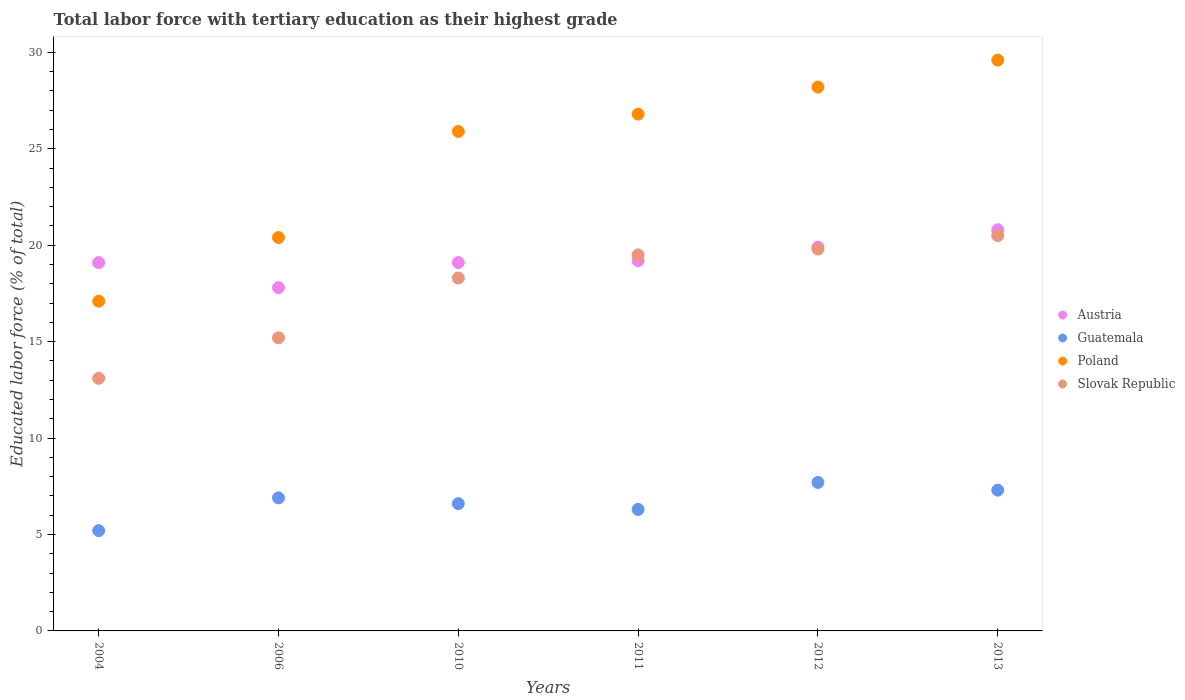What is the percentage of male labor force with tertiary education in Poland in 2010?
Ensure brevity in your answer.  25.9. Across all years, what is the maximum percentage of male labor force with tertiary education in Austria?
Make the answer very short. 20.8. Across all years, what is the minimum percentage of male labor force with tertiary education in Poland?
Your response must be concise. 17.1. What is the total percentage of male labor force with tertiary education in Slovak Republic in the graph?
Your answer should be compact. 106.4. What is the difference between the percentage of male labor force with tertiary education in Slovak Republic in 2010 and that in 2011?
Make the answer very short. -1.2. What is the difference between the percentage of male labor force with tertiary education in Poland in 2011 and the percentage of male labor force with tertiary education in Guatemala in 2012?
Provide a short and direct response. 19.1. What is the average percentage of male labor force with tertiary education in Austria per year?
Provide a short and direct response. 19.32. In the year 2006, what is the difference between the percentage of male labor force with tertiary education in Guatemala and percentage of male labor force with tertiary education in Slovak Republic?
Your response must be concise. -8.3. What is the ratio of the percentage of male labor force with tertiary education in Guatemala in 2004 to that in 2010?
Your answer should be compact. 0.79. What is the difference between the highest and the second highest percentage of male labor force with tertiary education in Guatemala?
Make the answer very short. 0.4. What is the difference between the highest and the lowest percentage of male labor force with tertiary education in Guatemala?
Provide a succinct answer. 2.5. In how many years, is the percentage of male labor force with tertiary education in Guatemala greater than the average percentage of male labor force with tertiary education in Guatemala taken over all years?
Ensure brevity in your answer.  3. Is the sum of the percentage of male labor force with tertiary education in Poland in 2004 and 2013 greater than the maximum percentage of male labor force with tertiary education in Guatemala across all years?
Your response must be concise. Yes. Is it the case that in every year, the sum of the percentage of male labor force with tertiary education in Poland and percentage of male labor force with tertiary education in Slovak Republic  is greater than the sum of percentage of male labor force with tertiary education in Austria and percentage of male labor force with tertiary education in Guatemala?
Your answer should be very brief. No. Is the percentage of male labor force with tertiary education in Guatemala strictly greater than the percentage of male labor force with tertiary education in Austria over the years?
Provide a succinct answer. No. How many dotlines are there?
Your response must be concise. 4. What is the difference between two consecutive major ticks on the Y-axis?
Ensure brevity in your answer.  5. Are the values on the major ticks of Y-axis written in scientific E-notation?
Offer a very short reply. No. Where does the legend appear in the graph?
Provide a succinct answer. Center right. What is the title of the graph?
Provide a short and direct response. Total labor force with tertiary education as their highest grade. Does "Europe(developing only)" appear as one of the legend labels in the graph?
Make the answer very short. No. What is the label or title of the X-axis?
Offer a terse response. Years. What is the label or title of the Y-axis?
Offer a terse response. Educated labor force (% of total). What is the Educated labor force (% of total) in Austria in 2004?
Offer a very short reply. 19.1. What is the Educated labor force (% of total) of Guatemala in 2004?
Offer a terse response. 5.2. What is the Educated labor force (% of total) in Poland in 2004?
Your response must be concise. 17.1. What is the Educated labor force (% of total) of Slovak Republic in 2004?
Offer a terse response. 13.1. What is the Educated labor force (% of total) in Austria in 2006?
Your answer should be compact. 17.8. What is the Educated labor force (% of total) of Guatemala in 2006?
Provide a succinct answer. 6.9. What is the Educated labor force (% of total) in Poland in 2006?
Offer a very short reply. 20.4. What is the Educated labor force (% of total) in Slovak Republic in 2006?
Offer a very short reply. 15.2. What is the Educated labor force (% of total) in Austria in 2010?
Your answer should be very brief. 19.1. What is the Educated labor force (% of total) in Guatemala in 2010?
Keep it short and to the point. 6.6. What is the Educated labor force (% of total) in Poland in 2010?
Give a very brief answer. 25.9. What is the Educated labor force (% of total) of Slovak Republic in 2010?
Give a very brief answer. 18.3. What is the Educated labor force (% of total) in Austria in 2011?
Make the answer very short. 19.2. What is the Educated labor force (% of total) of Guatemala in 2011?
Offer a very short reply. 6.3. What is the Educated labor force (% of total) of Poland in 2011?
Ensure brevity in your answer.  26.8. What is the Educated labor force (% of total) in Slovak Republic in 2011?
Your response must be concise. 19.5. What is the Educated labor force (% of total) of Austria in 2012?
Provide a succinct answer. 19.9. What is the Educated labor force (% of total) in Guatemala in 2012?
Give a very brief answer. 7.7. What is the Educated labor force (% of total) of Poland in 2012?
Your answer should be very brief. 28.2. What is the Educated labor force (% of total) in Slovak Republic in 2012?
Your response must be concise. 19.8. What is the Educated labor force (% of total) in Austria in 2013?
Give a very brief answer. 20.8. What is the Educated labor force (% of total) of Guatemala in 2013?
Give a very brief answer. 7.3. What is the Educated labor force (% of total) in Poland in 2013?
Your response must be concise. 29.6. Across all years, what is the maximum Educated labor force (% of total) of Austria?
Provide a succinct answer. 20.8. Across all years, what is the maximum Educated labor force (% of total) in Guatemala?
Your answer should be compact. 7.7. Across all years, what is the maximum Educated labor force (% of total) in Poland?
Provide a succinct answer. 29.6. Across all years, what is the minimum Educated labor force (% of total) of Austria?
Offer a terse response. 17.8. Across all years, what is the minimum Educated labor force (% of total) in Guatemala?
Offer a terse response. 5.2. Across all years, what is the minimum Educated labor force (% of total) of Poland?
Your response must be concise. 17.1. Across all years, what is the minimum Educated labor force (% of total) in Slovak Republic?
Offer a terse response. 13.1. What is the total Educated labor force (% of total) in Austria in the graph?
Make the answer very short. 115.9. What is the total Educated labor force (% of total) of Guatemala in the graph?
Give a very brief answer. 40. What is the total Educated labor force (% of total) in Poland in the graph?
Your response must be concise. 148. What is the total Educated labor force (% of total) of Slovak Republic in the graph?
Provide a short and direct response. 106.4. What is the difference between the Educated labor force (% of total) in Poland in 2004 and that in 2006?
Offer a terse response. -3.3. What is the difference between the Educated labor force (% of total) of Slovak Republic in 2004 and that in 2006?
Your response must be concise. -2.1. What is the difference between the Educated labor force (% of total) in Guatemala in 2004 and that in 2010?
Make the answer very short. -1.4. What is the difference between the Educated labor force (% of total) of Poland in 2004 and that in 2010?
Your answer should be very brief. -8.8. What is the difference between the Educated labor force (% of total) in Poland in 2004 and that in 2011?
Your response must be concise. -9.7. What is the difference between the Educated labor force (% of total) of Slovak Republic in 2004 and that in 2011?
Provide a succinct answer. -6.4. What is the difference between the Educated labor force (% of total) in Austria in 2004 and that in 2012?
Your response must be concise. -0.8. What is the difference between the Educated labor force (% of total) in Austria in 2004 and that in 2013?
Give a very brief answer. -1.7. What is the difference between the Educated labor force (% of total) in Poland in 2004 and that in 2013?
Give a very brief answer. -12.5. What is the difference between the Educated labor force (% of total) of Slovak Republic in 2004 and that in 2013?
Give a very brief answer. -7.4. What is the difference between the Educated labor force (% of total) of Guatemala in 2006 and that in 2010?
Ensure brevity in your answer.  0.3. What is the difference between the Educated labor force (% of total) in Slovak Republic in 2006 and that in 2010?
Your answer should be very brief. -3.1. What is the difference between the Educated labor force (% of total) in Slovak Republic in 2006 and that in 2011?
Give a very brief answer. -4.3. What is the difference between the Educated labor force (% of total) in Austria in 2006 and that in 2012?
Your answer should be compact. -2.1. What is the difference between the Educated labor force (% of total) of Slovak Republic in 2006 and that in 2012?
Offer a very short reply. -4.6. What is the difference between the Educated labor force (% of total) in Slovak Republic in 2006 and that in 2013?
Provide a succinct answer. -5.3. What is the difference between the Educated labor force (% of total) in Poland in 2010 and that in 2012?
Your response must be concise. -2.3. What is the difference between the Educated labor force (% of total) in Slovak Republic in 2010 and that in 2012?
Make the answer very short. -1.5. What is the difference between the Educated labor force (% of total) of Austria in 2010 and that in 2013?
Your response must be concise. -1.7. What is the difference between the Educated labor force (% of total) in Guatemala in 2010 and that in 2013?
Offer a terse response. -0.7. What is the difference between the Educated labor force (% of total) of Slovak Republic in 2010 and that in 2013?
Provide a succinct answer. -2.2. What is the difference between the Educated labor force (% of total) in Poland in 2011 and that in 2012?
Give a very brief answer. -1.4. What is the difference between the Educated labor force (% of total) of Slovak Republic in 2011 and that in 2012?
Your answer should be very brief. -0.3. What is the difference between the Educated labor force (% of total) in Austria in 2011 and that in 2013?
Offer a very short reply. -1.6. What is the difference between the Educated labor force (% of total) in Poland in 2011 and that in 2013?
Provide a short and direct response. -2.8. What is the difference between the Educated labor force (% of total) in Guatemala in 2004 and the Educated labor force (% of total) in Poland in 2006?
Ensure brevity in your answer.  -15.2. What is the difference between the Educated labor force (% of total) of Guatemala in 2004 and the Educated labor force (% of total) of Slovak Republic in 2006?
Offer a terse response. -10. What is the difference between the Educated labor force (% of total) in Poland in 2004 and the Educated labor force (% of total) in Slovak Republic in 2006?
Your answer should be very brief. 1.9. What is the difference between the Educated labor force (% of total) in Guatemala in 2004 and the Educated labor force (% of total) in Poland in 2010?
Make the answer very short. -20.7. What is the difference between the Educated labor force (% of total) of Poland in 2004 and the Educated labor force (% of total) of Slovak Republic in 2010?
Offer a terse response. -1.2. What is the difference between the Educated labor force (% of total) in Austria in 2004 and the Educated labor force (% of total) in Slovak Republic in 2011?
Keep it short and to the point. -0.4. What is the difference between the Educated labor force (% of total) of Guatemala in 2004 and the Educated labor force (% of total) of Poland in 2011?
Provide a succinct answer. -21.6. What is the difference between the Educated labor force (% of total) in Guatemala in 2004 and the Educated labor force (% of total) in Slovak Republic in 2011?
Ensure brevity in your answer.  -14.3. What is the difference between the Educated labor force (% of total) in Poland in 2004 and the Educated labor force (% of total) in Slovak Republic in 2011?
Provide a short and direct response. -2.4. What is the difference between the Educated labor force (% of total) in Austria in 2004 and the Educated labor force (% of total) in Guatemala in 2012?
Your answer should be compact. 11.4. What is the difference between the Educated labor force (% of total) of Austria in 2004 and the Educated labor force (% of total) of Poland in 2012?
Your answer should be very brief. -9.1. What is the difference between the Educated labor force (% of total) of Austria in 2004 and the Educated labor force (% of total) of Slovak Republic in 2012?
Offer a very short reply. -0.7. What is the difference between the Educated labor force (% of total) in Guatemala in 2004 and the Educated labor force (% of total) in Slovak Republic in 2012?
Ensure brevity in your answer.  -14.6. What is the difference between the Educated labor force (% of total) in Poland in 2004 and the Educated labor force (% of total) in Slovak Republic in 2012?
Offer a very short reply. -2.7. What is the difference between the Educated labor force (% of total) of Austria in 2004 and the Educated labor force (% of total) of Slovak Republic in 2013?
Make the answer very short. -1.4. What is the difference between the Educated labor force (% of total) of Guatemala in 2004 and the Educated labor force (% of total) of Poland in 2013?
Give a very brief answer. -24.4. What is the difference between the Educated labor force (% of total) in Guatemala in 2004 and the Educated labor force (% of total) in Slovak Republic in 2013?
Offer a terse response. -15.3. What is the difference between the Educated labor force (% of total) of Poland in 2004 and the Educated labor force (% of total) of Slovak Republic in 2013?
Your response must be concise. -3.4. What is the difference between the Educated labor force (% of total) in Austria in 2006 and the Educated labor force (% of total) in Slovak Republic in 2010?
Make the answer very short. -0.5. What is the difference between the Educated labor force (% of total) in Guatemala in 2006 and the Educated labor force (% of total) in Poland in 2010?
Provide a short and direct response. -19. What is the difference between the Educated labor force (% of total) of Poland in 2006 and the Educated labor force (% of total) of Slovak Republic in 2010?
Your answer should be very brief. 2.1. What is the difference between the Educated labor force (% of total) in Austria in 2006 and the Educated labor force (% of total) in Poland in 2011?
Provide a succinct answer. -9. What is the difference between the Educated labor force (% of total) in Austria in 2006 and the Educated labor force (% of total) in Slovak Republic in 2011?
Offer a terse response. -1.7. What is the difference between the Educated labor force (% of total) of Guatemala in 2006 and the Educated labor force (% of total) of Poland in 2011?
Provide a succinct answer. -19.9. What is the difference between the Educated labor force (% of total) of Guatemala in 2006 and the Educated labor force (% of total) of Slovak Republic in 2011?
Ensure brevity in your answer.  -12.6. What is the difference between the Educated labor force (% of total) of Poland in 2006 and the Educated labor force (% of total) of Slovak Republic in 2011?
Ensure brevity in your answer.  0.9. What is the difference between the Educated labor force (% of total) of Austria in 2006 and the Educated labor force (% of total) of Slovak Republic in 2012?
Your answer should be very brief. -2. What is the difference between the Educated labor force (% of total) of Guatemala in 2006 and the Educated labor force (% of total) of Poland in 2012?
Your answer should be very brief. -21.3. What is the difference between the Educated labor force (% of total) of Guatemala in 2006 and the Educated labor force (% of total) of Slovak Republic in 2012?
Provide a succinct answer. -12.9. What is the difference between the Educated labor force (% of total) in Austria in 2006 and the Educated labor force (% of total) in Slovak Republic in 2013?
Provide a short and direct response. -2.7. What is the difference between the Educated labor force (% of total) in Guatemala in 2006 and the Educated labor force (% of total) in Poland in 2013?
Offer a very short reply. -22.7. What is the difference between the Educated labor force (% of total) of Austria in 2010 and the Educated labor force (% of total) of Guatemala in 2011?
Your response must be concise. 12.8. What is the difference between the Educated labor force (% of total) in Austria in 2010 and the Educated labor force (% of total) in Slovak Republic in 2011?
Give a very brief answer. -0.4. What is the difference between the Educated labor force (% of total) in Guatemala in 2010 and the Educated labor force (% of total) in Poland in 2011?
Offer a very short reply. -20.2. What is the difference between the Educated labor force (% of total) of Guatemala in 2010 and the Educated labor force (% of total) of Slovak Republic in 2011?
Your answer should be very brief. -12.9. What is the difference between the Educated labor force (% of total) in Austria in 2010 and the Educated labor force (% of total) in Poland in 2012?
Provide a succinct answer. -9.1. What is the difference between the Educated labor force (% of total) of Austria in 2010 and the Educated labor force (% of total) of Slovak Republic in 2012?
Provide a succinct answer. -0.7. What is the difference between the Educated labor force (% of total) of Guatemala in 2010 and the Educated labor force (% of total) of Poland in 2012?
Ensure brevity in your answer.  -21.6. What is the difference between the Educated labor force (% of total) in Poland in 2010 and the Educated labor force (% of total) in Slovak Republic in 2012?
Make the answer very short. 6.1. What is the difference between the Educated labor force (% of total) of Austria in 2010 and the Educated labor force (% of total) of Guatemala in 2013?
Give a very brief answer. 11.8. What is the difference between the Educated labor force (% of total) in Austria in 2010 and the Educated labor force (% of total) in Poland in 2013?
Offer a very short reply. -10.5. What is the difference between the Educated labor force (% of total) of Guatemala in 2010 and the Educated labor force (% of total) of Slovak Republic in 2013?
Provide a succinct answer. -13.9. What is the difference between the Educated labor force (% of total) of Poland in 2010 and the Educated labor force (% of total) of Slovak Republic in 2013?
Provide a succinct answer. 5.4. What is the difference between the Educated labor force (% of total) of Austria in 2011 and the Educated labor force (% of total) of Guatemala in 2012?
Your response must be concise. 11.5. What is the difference between the Educated labor force (% of total) in Austria in 2011 and the Educated labor force (% of total) in Slovak Republic in 2012?
Your response must be concise. -0.6. What is the difference between the Educated labor force (% of total) of Guatemala in 2011 and the Educated labor force (% of total) of Poland in 2012?
Your response must be concise. -21.9. What is the difference between the Educated labor force (% of total) in Guatemala in 2011 and the Educated labor force (% of total) in Slovak Republic in 2012?
Provide a short and direct response. -13.5. What is the difference between the Educated labor force (% of total) in Poland in 2011 and the Educated labor force (% of total) in Slovak Republic in 2012?
Provide a succinct answer. 7. What is the difference between the Educated labor force (% of total) of Austria in 2011 and the Educated labor force (% of total) of Guatemala in 2013?
Ensure brevity in your answer.  11.9. What is the difference between the Educated labor force (% of total) in Guatemala in 2011 and the Educated labor force (% of total) in Poland in 2013?
Keep it short and to the point. -23.3. What is the difference between the Educated labor force (% of total) of Poland in 2011 and the Educated labor force (% of total) of Slovak Republic in 2013?
Your answer should be compact. 6.3. What is the difference between the Educated labor force (% of total) in Austria in 2012 and the Educated labor force (% of total) in Guatemala in 2013?
Your response must be concise. 12.6. What is the difference between the Educated labor force (% of total) in Austria in 2012 and the Educated labor force (% of total) in Slovak Republic in 2013?
Provide a succinct answer. -0.6. What is the difference between the Educated labor force (% of total) in Guatemala in 2012 and the Educated labor force (% of total) in Poland in 2013?
Ensure brevity in your answer.  -21.9. What is the difference between the Educated labor force (% of total) in Poland in 2012 and the Educated labor force (% of total) in Slovak Republic in 2013?
Ensure brevity in your answer.  7.7. What is the average Educated labor force (% of total) in Austria per year?
Offer a very short reply. 19.32. What is the average Educated labor force (% of total) of Poland per year?
Your answer should be very brief. 24.67. What is the average Educated labor force (% of total) of Slovak Republic per year?
Provide a short and direct response. 17.73. In the year 2004, what is the difference between the Educated labor force (% of total) of Austria and Educated labor force (% of total) of Guatemala?
Your response must be concise. 13.9. In the year 2004, what is the difference between the Educated labor force (% of total) in Guatemala and Educated labor force (% of total) in Slovak Republic?
Provide a succinct answer. -7.9. In the year 2004, what is the difference between the Educated labor force (% of total) in Poland and Educated labor force (% of total) in Slovak Republic?
Your response must be concise. 4. In the year 2006, what is the difference between the Educated labor force (% of total) of Austria and Educated labor force (% of total) of Guatemala?
Offer a very short reply. 10.9. In the year 2006, what is the difference between the Educated labor force (% of total) of Austria and Educated labor force (% of total) of Poland?
Ensure brevity in your answer.  -2.6. In the year 2006, what is the difference between the Educated labor force (% of total) in Austria and Educated labor force (% of total) in Slovak Republic?
Offer a terse response. 2.6. In the year 2006, what is the difference between the Educated labor force (% of total) in Guatemala and Educated labor force (% of total) in Poland?
Keep it short and to the point. -13.5. In the year 2010, what is the difference between the Educated labor force (% of total) of Austria and Educated labor force (% of total) of Guatemala?
Ensure brevity in your answer.  12.5. In the year 2010, what is the difference between the Educated labor force (% of total) of Austria and Educated labor force (% of total) of Poland?
Offer a very short reply. -6.8. In the year 2010, what is the difference between the Educated labor force (% of total) of Guatemala and Educated labor force (% of total) of Poland?
Give a very brief answer. -19.3. In the year 2010, what is the difference between the Educated labor force (% of total) in Poland and Educated labor force (% of total) in Slovak Republic?
Ensure brevity in your answer.  7.6. In the year 2011, what is the difference between the Educated labor force (% of total) of Austria and Educated labor force (% of total) of Poland?
Your response must be concise. -7.6. In the year 2011, what is the difference between the Educated labor force (% of total) of Austria and Educated labor force (% of total) of Slovak Republic?
Offer a very short reply. -0.3. In the year 2011, what is the difference between the Educated labor force (% of total) of Guatemala and Educated labor force (% of total) of Poland?
Your answer should be very brief. -20.5. In the year 2011, what is the difference between the Educated labor force (% of total) in Guatemala and Educated labor force (% of total) in Slovak Republic?
Provide a short and direct response. -13.2. In the year 2011, what is the difference between the Educated labor force (% of total) of Poland and Educated labor force (% of total) of Slovak Republic?
Offer a terse response. 7.3. In the year 2012, what is the difference between the Educated labor force (% of total) in Austria and Educated labor force (% of total) in Guatemala?
Offer a very short reply. 12.2. In the year 2012, what is the difference between the Educated labor force (% of total) in Guatemala and Educated labor force (% of total) in Poland?
Offer a terse response. -20.5. In the year 2013, what is the difference between the Educated labor force (% of total) in Austria and Educated labor force (% of total) in Guatemala?
Provide a short and direct response. 13.5. In the year 2013, what is the difference between the Educated labor force (% of total) in Austria and Educated labor force (% of total) in Poland?
Offer a terse response. -8.8. In the year 2013, what is the difference between the Educated labor force (% of total) in Austria and Educated labor force (% of total) in Slovak Republic?
Provide a short and direct response. 0.3. In the year 2013, what is the difference between the Educated labor force (% of total) of Guatemala and Educated labor force (% of total) of Poland?
Offer a very short reply. -22.3. In the year 2013, what is the difference between the Educated labor force (% of total) of Guatemala and Educated labor force (% of total) of Slovak Republic?
Ensure brevity in your answer.  -13.2. In the year 2013, what is the difference between the Educated labor force (% of total) in Poland and Educated labor force (% of total) in Slovak Republic?
Your response must be concise. 9.1. What is the ratio of the Educated labor force (% of total) in Austria in 2004 to that in 2006?
Provide a short and direct response. 1.07. What is the ratio of the Educated labor force (% of total) of Guatemala in 2004 to that in 2006?
Your answer should be very brief. 0.75. What is the ratio of the Educated labor force (% of total) of Poland in 2004 to that in 2006?
Your answer should be compact. 0.84. What is the ratio of the Educated labor force (% of total) of Slovak Republic in 2004 to that in 2006?
Provide a succinct answer. 0.86. What is the ratio of the Educated labor force (% of total) in Guatemala in 2004 to that in 2010?
Your answer should be very brief. 0.79. What is the ratio of the Educated labor force (% of total) of Poland in 2004 to that in 2010?
Offer a terse response. 0.66. What is the ratio of the Educated labor force (% of total) of Slovak Republic in 2004 to that in 2010?
Your response must be concise. 0.72. What is the ratio of the Educated labor force (% of total) of Guatemala in 2004 to that in 2011?
Give a very brief answer. 0.83. What is the ratio of the Educated labor force (% of total) in Poland in 2004 to that in 2011?
Your answer should be very brief. 0.64. What is the ratio of the Educated labor force (% of total) of Slovak Republic in 2004 to that in 2011?
Make the answer very short. 0.67. What is the ratio of the Educated labor force (% of total) in Austria in 2004 to that in 2012?
Offer a very short reply. 0.96. What is the ratio of the Educated labor force (% of total) in Guatemala in 2004 to that in 2012?
Offer a very short reply. 0.68. What is the ratio of the Educated labor force (% of total) in Poland in 2004 to that in 2012?
Your answer should be compact. 0.61. What is the ratio of the Educated labor force (% of total) in Slovak Republic in 2004 to that in 2012?
Your answer should be very brief. 0.66. What is the ratio of the Educated labor force (% of total) of Austria in 2004 to that in 2013?
Your answer should be very brief. 0.92. What is the ratio of the Educated labor force (% of total) of Guatemala in 2004 to that in 2013?
Your answer should be very brief. 0.71. What is the ratio of the Educated labor force (% of total) in Poland in 2004 to that in 2013?
Offer a terse response. 0.58. What is the ratio of the Educated labor force (% of total) of Slovak Republic in 2004 to that in 2013?
Your answer should be compact. 0.64. What is the ratio of the Educated labor force (% of total) of Austria in 2006 to that in 2010?
Your answer should be very brief. 0.93. What is the ratio of the Educated labor force (% of total) in Guatemala in 2006 to that in 2010?
Keep it short and to the point. 1.05. What is the ratio of the Educated labor force (% of total) in Poland in 2006 to that in 2010?
Make the answer very short. 0.79. What is the ratio of the Educated labor force (% of total) in Slovak Republic in 2006 to that in 2010?
Your response must be concise. 0.83. What is the ratio of the Educated labor force (% of total) in Austria in 2006 to that in 2011?
Your response must be concise. 0.93. What is the ratio of the Educated labor force (% of total) of Guatemala in 2006 to that in 2011?
Your answer should be very brief. 1.1. What is the ratio of the Educated labor force (% of total) in Poland in 2006 to that in 2011?
Your answer should be compact. 0.76. What is the ratio of the Educated labor force (% of total) in Slovak Republic in 2006 to that in 2011?
Provide a short and direct response. 0.78. What is the ratio of the Educated labor force (% of total) of Austria in 2006 to that in 2012?
Keep it short and to the point. 0.89. What is the ratio of the Educated labor force (% of total) in Guatemala in 2006 to that in 2012?
Offer a very short reply. 0.9. What is the ratio of the Educated labor force (% of total) in Poland in 2006 to that in 2012?
Keep it short and to the point. 0.72. What is the ratio of the Educated labor force (% of total) in Slovak Republic in 2006 to that in 2012?
Ensure brevity in your answer.  0.77. What is the ratio of the Educated labor force (% of total) in Austria in 2006 to that in 2013?
Offer a terse response. 0.86. What is the ratio of the Educated labor force (% of total) in Guatemala in 2006 to that in 2013?
Provide a succinct answer. 0.95. What is the ratio of the Educated labor force (% of total) in Poland in 2006 to that in 2013?
Your response must be concise. 0.69. What is the ratio of the Educated labor force (% of total) in Slovak Republic in 2006 to that in 2013?
Keep it short and to the point. 0.74. What is the ratio of the Educated labor force (% of total) of Guatemala in 2010 to that in 2011?
Provide a short and direct response. 1.05. What is the ratio of the Educated labor force (% of total) in Poland in 2010 to that in 2011?
Ensure brevity in your answer.  0.97. What is the ratio of the Educated labor force (% of total) of Slovak Republic in 2010 to that in 2011?
Provide a succinct answer. 0.94. What is the ratio of the Educated labor force (% of total) in Austria in 2010 to that in 2012?
Your answer should be compact. 0.96. What is the ratio of the Educated labor force (% of total) of Guatemala in 2010 to that in 2012?
Give a very brief answer. 0.86. What is the ratio of the Educated labor force (% of total) of Poland in 2010 to that in 2012?
Keep it short and to the point. 0.92. What is the ratio of the Educated labor force (% of total) of Slovak Republic in 2010 to that in 2012?
Your answer should be very brief. 0.92. What is the ratio of the Educated labor force (% of total) of Austria in 2010 to that in 2013?
Ensure brevity in your answer.  0.92. What is the ratio of the Educated labor force (% of total) of Guatemala in 2010 to that in 2013?
Your response must be concise. 0.9. What is the ratio of the Educated labor force (% of total) of Poland in 2010 to that in 2013?
Ensure brevity in your answer.  0.88. What is the ratio of the Educated labor force (% of total) in Slovak Republic in 2010 to that in 2013?
Your answer should be very brief. 0.89. What is the ratio of the Educated labor force (% of total) in Austria in 2011 to that in 2012?
Keep it short and to the point. 0.96. What is the ratio of the Educated labor force (% of total) of Guatemala in 2011 to that in 2012?
Provide a short and direct response. 0.82. What is the ratio of the Educated labor force (% of total) in Poland in 2011 to that in 2012?
Your response must be concise. 0.95. What is the ratio of the Educated labor force (% of total) of Austria in 2011 to that in 2013?
Provide a succinct answer. 0.92. What is the ratio of the Educated labor force (% of total) of Guatemala in 2011 to that in 2013?
Ensure brevity in your answer.  0.86. What is the ratio of the Educated labor force (% of total) in Poland in 2011 to that in 2013?
Ensure brevity in your answer.  0.91. What is the ratio of the Educated labor force (% of total) of Slovak Republic in 2011 to that in 2013?
Offer a terse response. 0.95. What is the ratio of the Educated labor force (% of total) of Austria in 2012 to that in 2013?
Your answer should be compact. 0.96. What is the ratio of the Educated labor force (% of total) in Guatemala in 2012 to that in 2013?
Your answer should be compact. 1.05. What is the ratio of the Educated labor force (% of total) in Poland in 2012 to that in 2013?
Your response must be concise. 0.95. What is the ratio of the Educated labor force (% of total) in Slovak Republic in 2012 to that in 2013?
Provide a succinct answer. 0.97. What is the difference between the highest and the second highest Educated labor force (% of total) in Austria?
Your answer should be very brief. 0.9. What is the difference between the highest and the second highest Educated labor force (% of total) of Guatemala?
Your answer should be compact. 0.4. What is the difference between the highest and the second highest Educated labor force (% of total) in Slovak Republic?
Make the answer very short. 0.7. What is the difference between the highest and the lowest Educated labor force (% of total) in Austria?
Your answer should be compact. 3. 